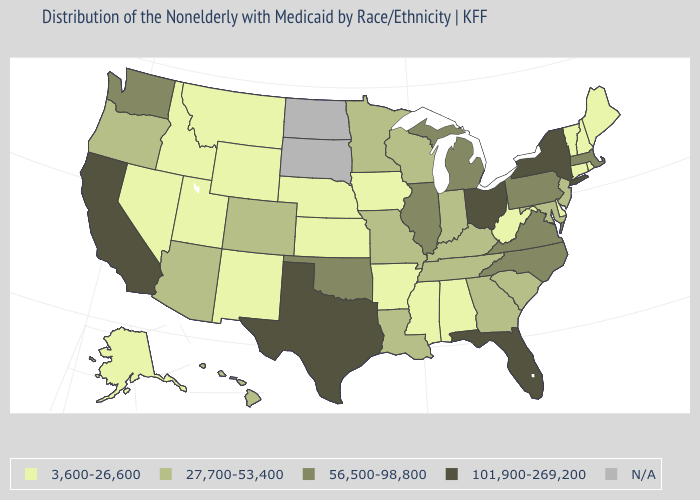What is the lowest value in the MidWest?
Short answer required. 3,600-26,600. What is the value of Texas?
Be succinct. 101,900-269,200. What is the value of Hawaii?
Concise answer only. 27,700-53,400. What is the lowest value in the USA?
Answer briefly. 3,600-26,600. Which states have the lowest value in the USA?
Be succinct. Alabama, Alaska, Arkansas, Connecticut, Delaware, Idaho, Iowa, Kansas, Maine, Mississippi, Montana, Nebraska, Nevada, New Hampshire, New Mexico, Rhode Island, Utah, Vermont, West Virginia, Wyoming. Name the states that have a value in the range N/A?
Be succinct. North Dakota, South Dakota. Does Nevada have the lowest value in the USA?
Short answer required. Yes. Which states hav the highest value in the Northeast?
Concise answer only. New York. What is the value of Nebraska?
Keep it brief. 3,600-26,600. Name the states that have a value in the range N/A?
Give a very brief answer. North Dakota, South Dakota. What is the lowest value in the MidWest?
Write a very short answer. 3,600-26,600. Does Texas have the highest value in the South?
Be succinct. Yes. Among the states that border New York , which have the highest value?
Give a very brief answer. Massachusetts, Pennsylvania. 